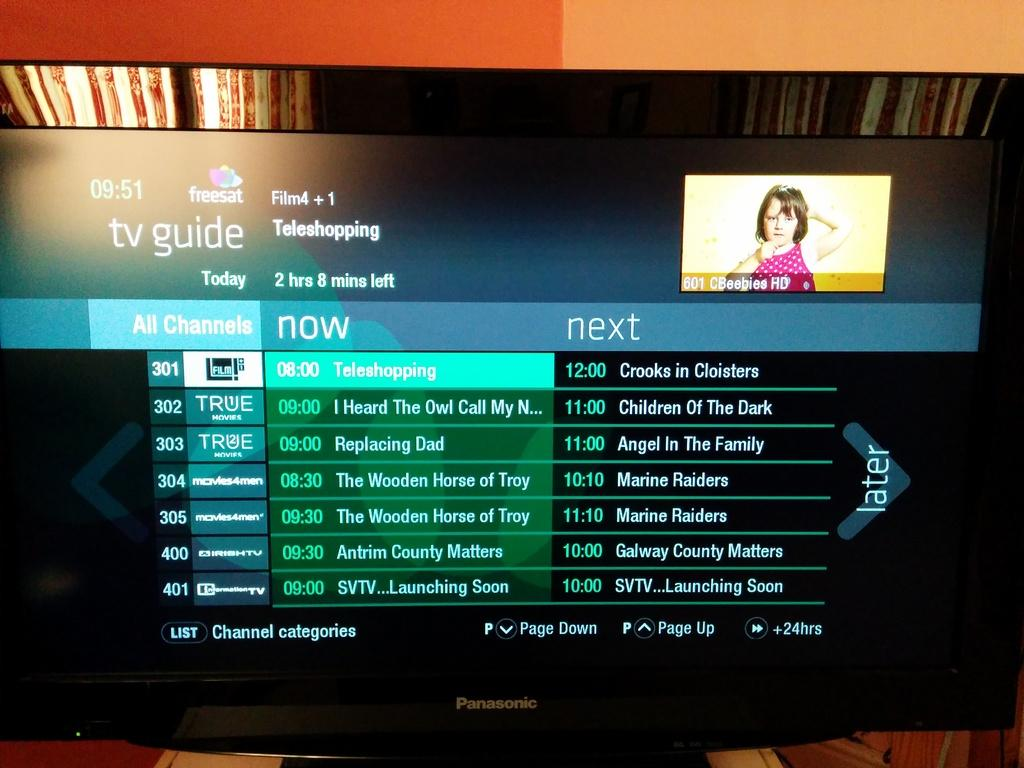<image>
Describe the image concisely. Television screen that has the words "TV Guide" on the top. 